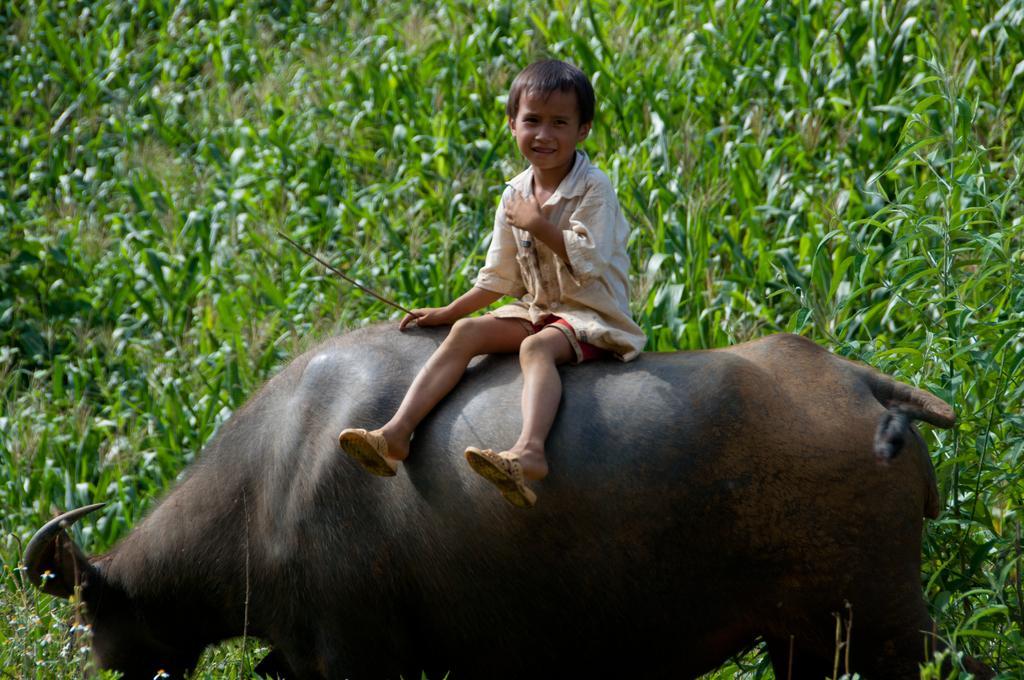In one or two sentences, can you explain what this image depicts? This is the picture of a grass field. In this image there is a boy sitting on the buffalo and he is smiling and he is holding the stick. 